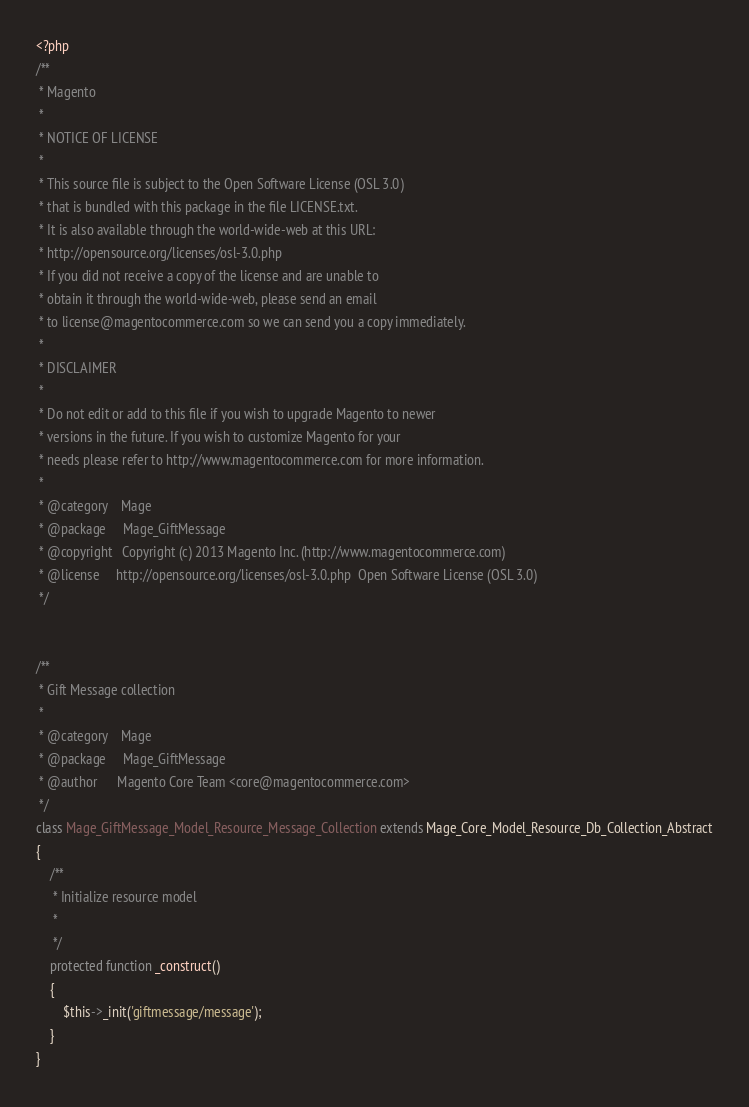<code> <loc_0><loc_0><loc_500><loc_500><_PHP_><?php
/**
 * Magento
 *
 * NOTICE OF LICENSE
 *
 * This source file is subject to the Open Software License (OSL 3.0)
 * that is bundled with this package in the file LICENSE.txt.
 * It is also available through the world-wide-web at this URL:
 * http://opensource.org/licenses/osl-3.0.php
 * If you did not receive a copy of the license and are unable to
 * obtain it through the world-wide-web, please send an email
 * to license@magentocommerce.com so we can send you a copy immediately.
 *
 * DISCLAIMER
 *
 * Do not edit or add to this file if you wish to upgrade Magento to newer
 * versions in the future. If you wish to customize Magento for your
 * needs please refer to http://www.magentocommerce.com for more information.
 *
 * @category    Mage
 * @package     Mage_GiftMessage
 * @copyright   Copyright (c) 2013 Magento Inc. (http://www.magentocommerce.com)
 * @license     http://opensource.org/licenses/osl-3.0.php  Open Software License (OSL 3.0)
 */


/**
 * Gift Message collection
 *
 * @category    Mage
 * @package     Mage_GiftMessage
 * @author      Magento Core Team <core@magentocommerce.com>
 */
class Mage_GiftMessage_Model_Resource_Message_Collection extends Mage_Core_Model_Resource_Db_Collection_Abstract
{
    /**
     * Initialize resource model
     *
     */
    protected function _construct()
    {
        $this->_init('giftmessage/message');
    }
}
</code> 